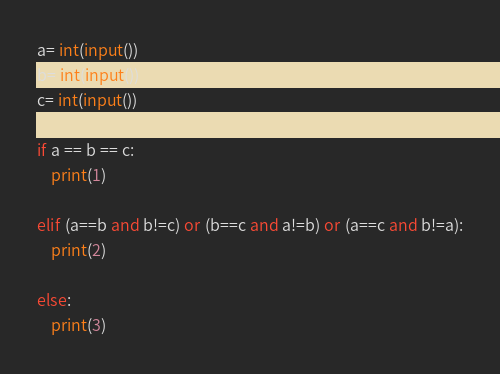Convert code to text. <code><loc_0><loc_0><loc_500><loc_500><_Python_>a= int(input())
b= int(input())
c= int(input())

if a == b == c:
    print(1)

elif (a==b and b!=c) or (b==c and a!=b) or (a==c and b!=a):
    print(2)

else:
    print(3)

</code> 